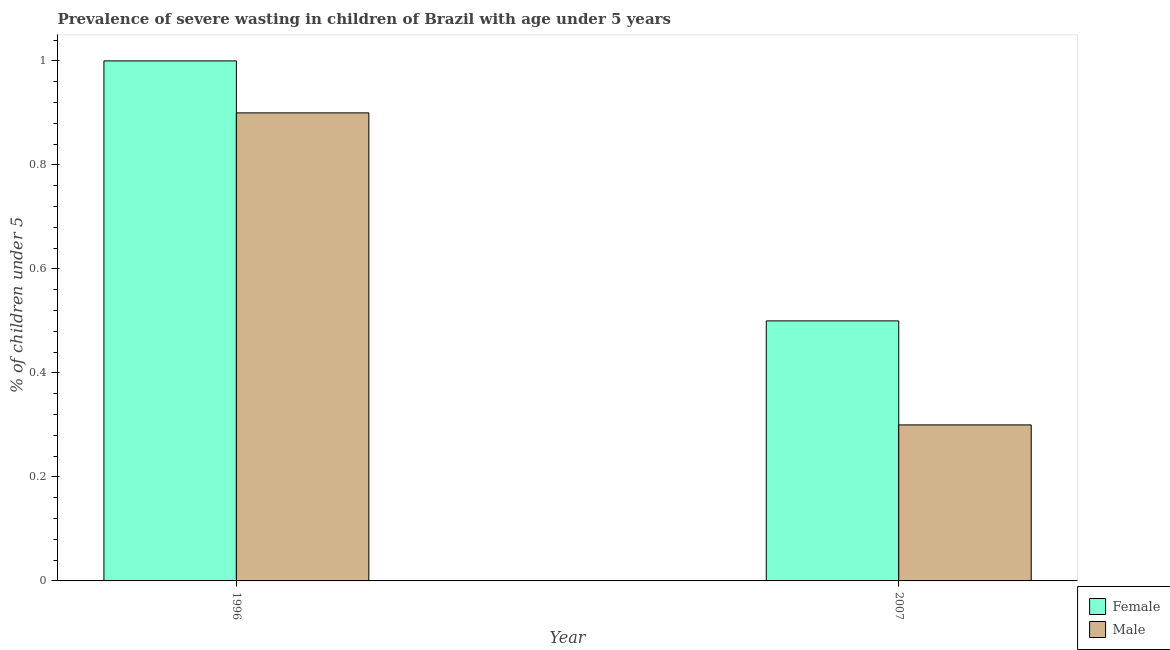How many different coloured bars are there?
Ensure brevity in your answer.  2. Are the number of bars per tick equal to the number of legend labels?
Ensure brevity in your answer.  Yes. How many bars are there on the 2nd tick from the left?
Your answer should be compact. 2. What is the label of the 2nd group of bars from the left?
Ensure brevity in your answer.  2007. In how many cases, is the number of bars for a given year not equal to the number of legend labels?
Provide a succinct answer. 0. Across all years, what is the maximum percentage of undernourished male children?
Provide a succinct answer. 0.9. Across all years, what is the minimum percentage of undernourished male children?
Your answer should be very brief. 0.3. In which year was the percentage of undernourished male children minimum?
Your answer should be compact. 2007. What is the total percentage of undernourished male children in the graph?
Ensure brevity in your answer.  1.2. What is the difference between the percentage of undernourished male children in 1996 and the percentage of undernourished female children in 2007?
Offer a terse response. 0.6. In the year 2007, what is the difference between the percentage of undernourished male children and percentage of undernourished female children?
Provide a short and direct response. 0. In how many years, is the percentage of undernourished female children greater than 0.7200000000000001 %?
Offer a terse response. 1. What is the ratio of the percentage of undernourished male children in 1996 to that in 2007?
Keep it short and to the point. 3. Is the percentage of undernourished female children in 1996 less than that in 2007?
Provide a short and direct response. No. Are all the bars in the graph horizontal?
Provide a short and direct response. No. How many years are there in the graph?
Your answer should be compact. 2. What is the difference between two consecutive major ticks on the Y-axis?
Your answer should be very brief. 0.2. Are the values on the major ticks of Y-axis written in scientific E-notation?
Provide a short and direct response. No. Does the graph contain any zero values?
Your answer should be very brief. No. Does the graph contain grids?
Offer a terse response. No. Where does the legend appear in the graph?
Keep it short and to the point. Bottom right. How are the legend labels stacked?
Your response must be concise. Vertical. What is the title of the graph?
Your answer should be compact. Prevalence of severe wasting in children of Brazil with age under 5 years. What is the label or title of the X-axis?
Provide a short and direct response. Year. What is the label or title of the Y-axis?
Offer a very short reply.  % of children under 5. What is the  % of children under 5 in Female in 1996?
Your answer should be very brief. 1. What is the  % of children under 5 of Male in 1996?
Your answer should be very brief. 0.9. What is the  % of children under 5 of Male in 2007?
Provide a short and direct response. 0.3. Across all years, what is the maximum  % of children under 5 of Female?
Provide a short and direct response. 1. Across all years, what is the maximum  % of children under 5 of Male?
Your response must be concise. 0.9. Across all years, what is the minimum  % of children under 5 of Female?
Make the answer very short. 0.5. Across all years, what is the minimum  % of children under 5 of Male?
Make the answer very short. 0.3. What is the total  % of children under 5 in Female in the graph?
Offer a very short reply. 1.5. What is the total  % of children under 5 of Male in the graph?
Provide a succinct answer. 1.2. What is the difference between the  % of children under 5 of Female in 1996 and that in 2007?
Your answer should be very brief. 0.5. What is the average  % of children under 5 in Male per year?
Give a very brief answer. 0.6. In the year 2007, what is the difference between the  % of children under 5 of Female and  % of children under 5 of Male?
Give a very brief answer. 0.2. What is the ratio of the  % of children under 5 in Female in 1996 to that in 2007?
Keep it short and to the point. 2. 